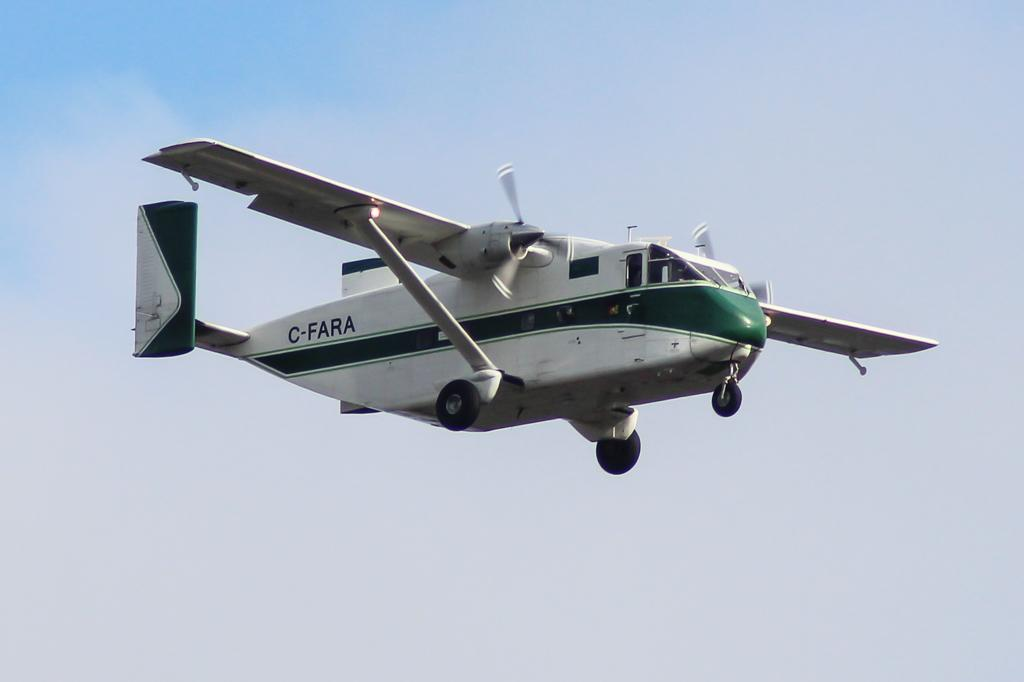<image>
Present a compact description of the photo's key features. The small plane is white and green and has C-FARA written on the side. 